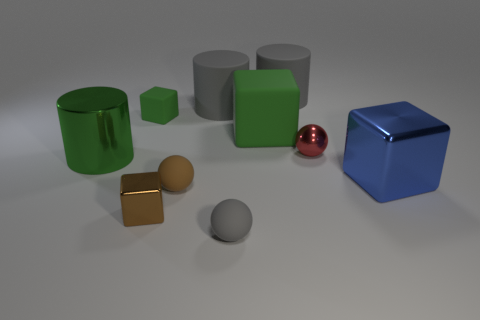Subtract all cyan balls. Subtract all gray cylinders. How many balls are left? 3 Subtract all cubes. How many objects are left? 6 Add 1 tiny brown cubes. How many tiny brown cubes exist? 2 Subtract 2 gray cylinders. How many objects are left? 8 Subtract all tiny red metal things. Subtract all large blue cubes. How many objects are left? 8 Add 1 small red metallic spheres. How many small red metallic spheres are left? 2 